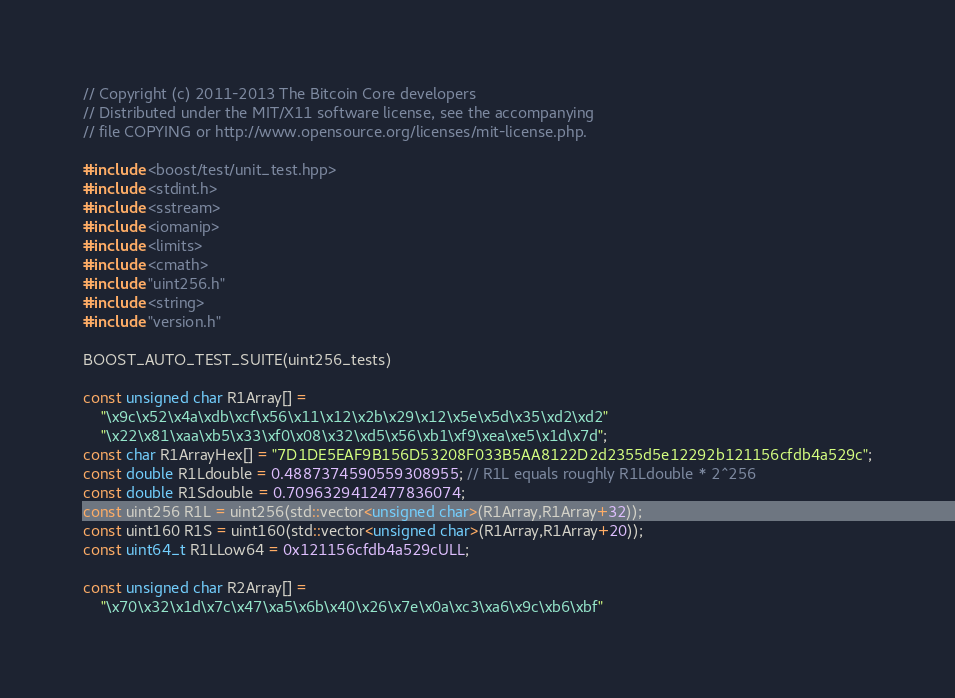Convert code to text. <code><loc_0><loc_0><loc_500><loc_500><_C++_>// Copyright (c) 2011-2013 The Bitcoin Core developers
// Distributed under the MIT/X11 software license, see the accompanying
// file COPYING or http://www.opensource.org/licenses/mit-license.php.

#include <boost/test/unit_test.hpp>
#include <stdint.h>
#include <sstream>
#include <iomanip>
#include <limits>
#include <cmath>
#include "uint256.h"
#include <string>
#include "version.h"

BOOST_AUTO_TEST_SUITE(uint256_tests)
 
const unsigned char R1Array[] = 
    "\x9c\x52\x4a\xdb\xcf\x56\x11\x12\x2b\x29\x12\x5e\x5d\x35\xd2\xd2"
    "\x22\x81\xaa\xb5\x33\xf0\x08\x32\xd5\x56\xb1\xf9\xea\xe5\x1d\x7d";
const char R1ArrayHex[] = "7D1DE5EAF9B156D53208F033B5AA8122D2d2355d5e12292b121156cfdb4a529c";
const double R1Ldouble = 0.4887374590559308955; // R1L equals roughly R1Ldouble * 2^256
const double R1Sdouble = 0.7096329412477836074; 
const uint256 R1L = uint256(std::vector<unsigned char>(R1Array,R1Array+32));
const uint160 R1S = uint160(std::vector<unsigned char>(R1Array,R1Array+20));
const uint64_t R1LLow64 = 0x121156cfdb4a529cULL;

const unsigned char R2Array[] = 
    "\x70\x32\x1d\x7c\x47\xa5\x6b\x40\x26\x7e\x0a\xc3\xa6\x9c\xb6\xbf"</code> 